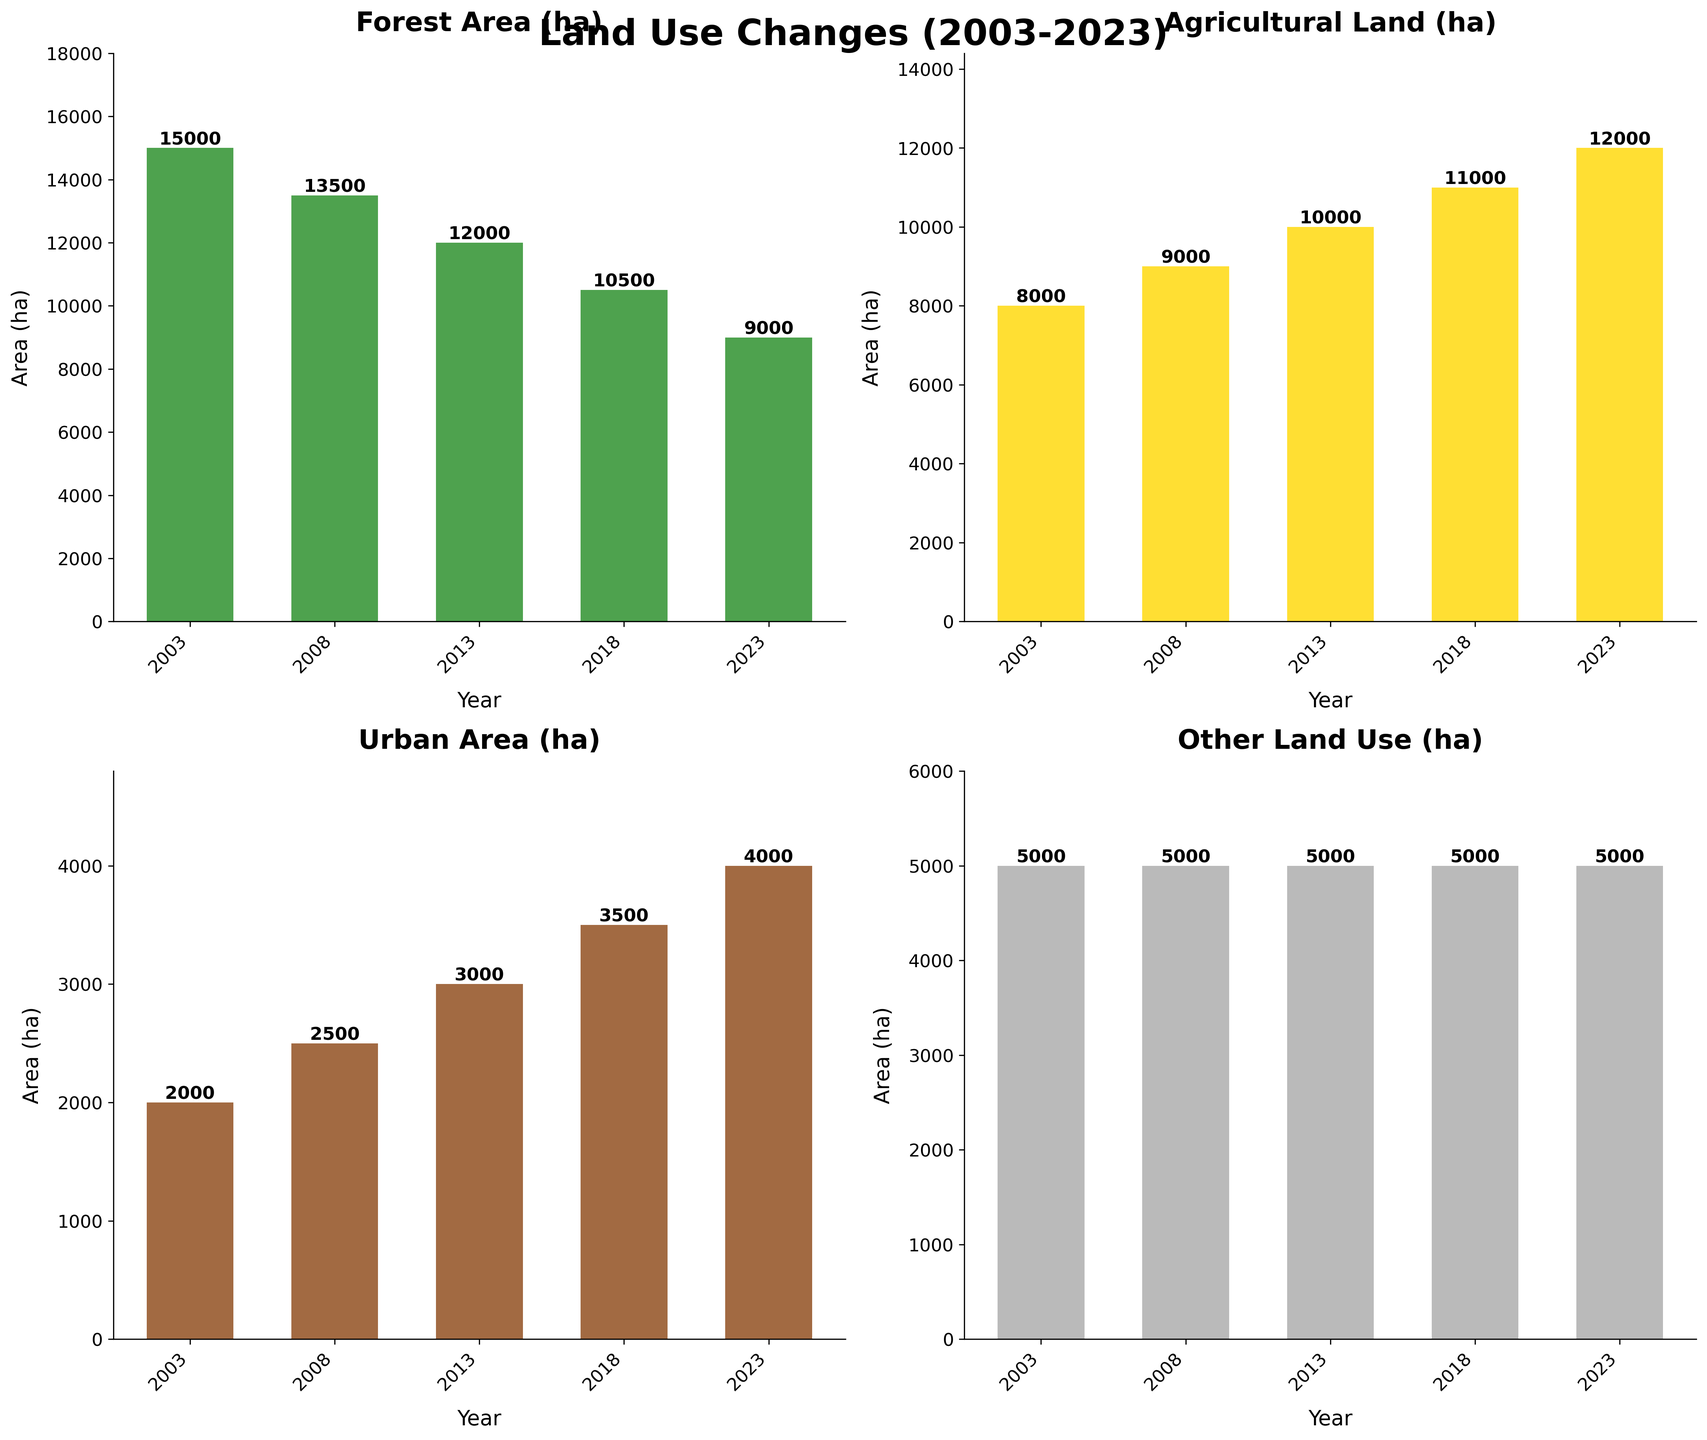What's the trend in Agricultural Land (ha) from 2003 to 2023? Observe the height of the bars for Agricultural Land (ha) in each year from 2003 to 2023. Note that the bars progressively increase over time.
Answer: Increasing trend What's the difference in Forest Area (ha) between 2003 and 2023? Look at the values for Forest Area in 2003 (15000 ha) and 2023 (9000 ha). Subtract the 2023 value from the 2003 value: 15000 - 9000.
Answer: 6000 ha Which land use category had the largest increase in area from 2003 to 2023? Compare the changes in area for each category: Forest Area decreased, Agricultural Land increased by 4000 ha, Urban Area increased by 2000 ha, and Other Land Use stayed constant. The largest increase is in Agricultural Land.
Answer: Agricultural Land What is the sum of Urban Area (ha) for all the years presented? Add the values of Urban Area for each year: 2000 + 2500 + 3000 + 3500 + 4000.
Answer: 15000 ha What is the average Forest Area (ha) for the years provided? Sum the Forest Area values (15000 + 13500 + 12000 + 10500 + 9000) and divide by the number of years (5): (15000 + 13500 + 12000 + 10500 + 9000) / 5.
Answer: 12000 ha Between which consecutive years did Urban Area (ha) see the largest increase? Compare the differences in Urban Area between consecutive years: 2003-2008 (500 ha), 2008-2013 (500 ha), 2013-2018 (500 ha), 2018-2023 (500 ha). All increases are equal.
Answer: 2003-2008, 2008-2013, 2013-2018, 2018-2023 How much has Agricultural Land (ha) increased from 2013 to 2023? Subtract the Agricultural Land value in 2013 (10000 ha) from the value in 2023 (12000 ha): 12000 - 10000.
Answer: 2000 ha What percentage of the total land area in 2023 is occupied by Forest Area (ha)? First, sum all land areas for 2023: 9000 + 12000 + 4000 + 5000 = 30000. Then, divide Forest Area by total area and multiply by 100: (9000 / 30000) * 100.
Answer: 30% 